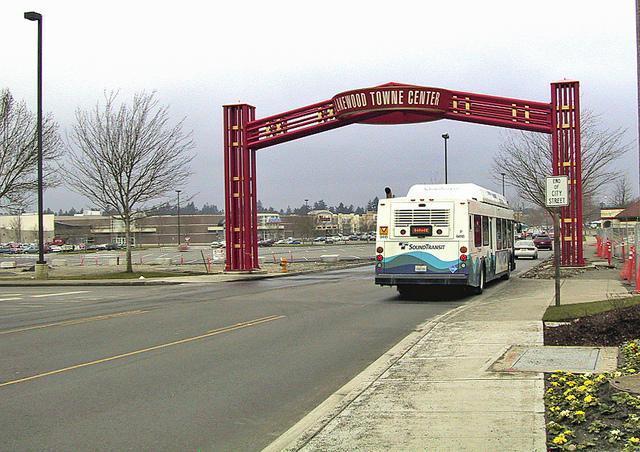How many zebra are there?
Give a very brief answer. 0. 